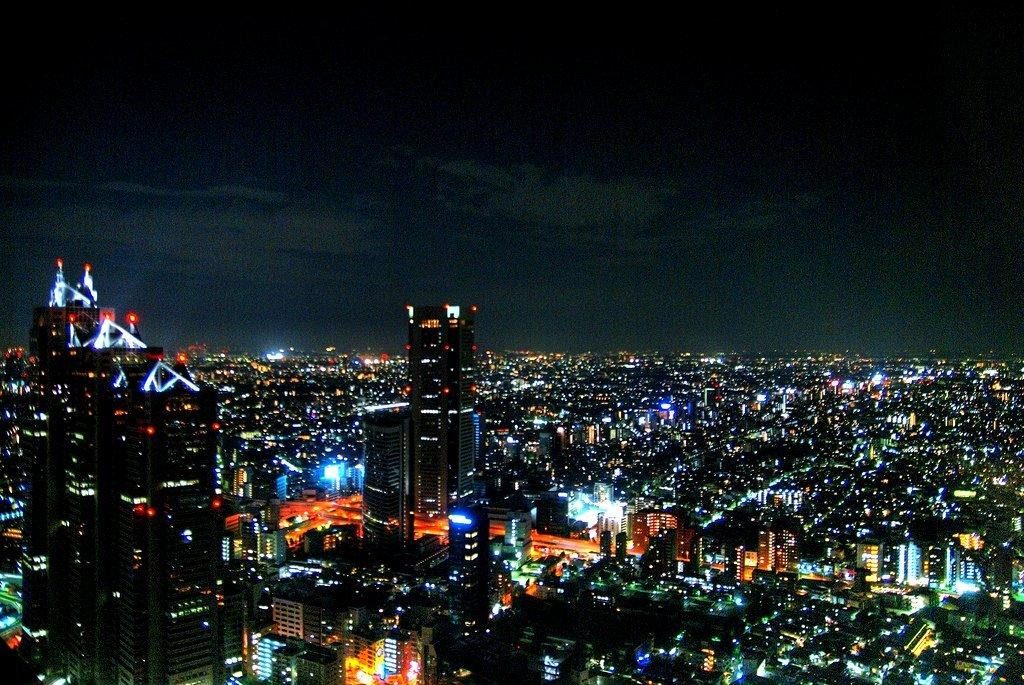What type of structures are present in the image? There are buildings and skyscrapers in the image. What can be seen on the ground in the image? There is a walkway in the image. Are there any sources of illumination in the image? Yes, there are lights in the image. What is visible at the top of the image? The sky is visible at the top of the image. What type of sugar is being used to sweeten the airplane in the image? There is no airplane present in the image, and therefore no sugar or sweetening is involved. 